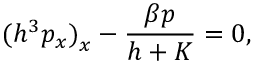Convert formula to latex. <formula><loc_0><loc_0><loc_500><loc_500>{ ( h ^ { 3 } p _ { x } ) } _ { x } - { \frac { \beta p } { h + K } } = 0 ,</formula> 